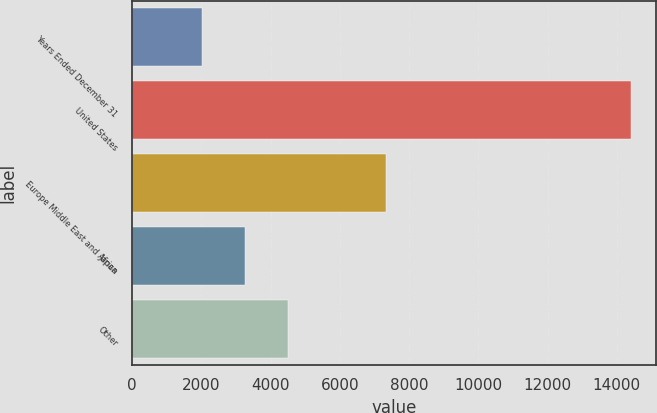<chart> <loc_0><loc_0><loc_500><loc_500><bar_chart><fcel>Years Ended December 31<fcel>United States<fcel>Europe Middle East and Africa<fcel>Japan<fcel>Other<nl><fcel>2009<fcel>14401<fcel>7326<fcel>3248.2<fcel>4487.4<nl></chart> 